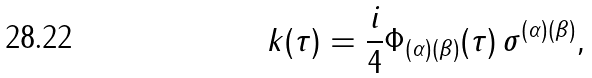Convert formula to latex. <formula><loc_0><loc_0><loc_500><loc_500>k ( \tau ) = \frac { i } { 4 } \Phi _ { ( \alpha ) ( \beta ) } ( \tau ) \, \sigma ^ { ( \alpha ) ( \beta ) } ,</formula> 